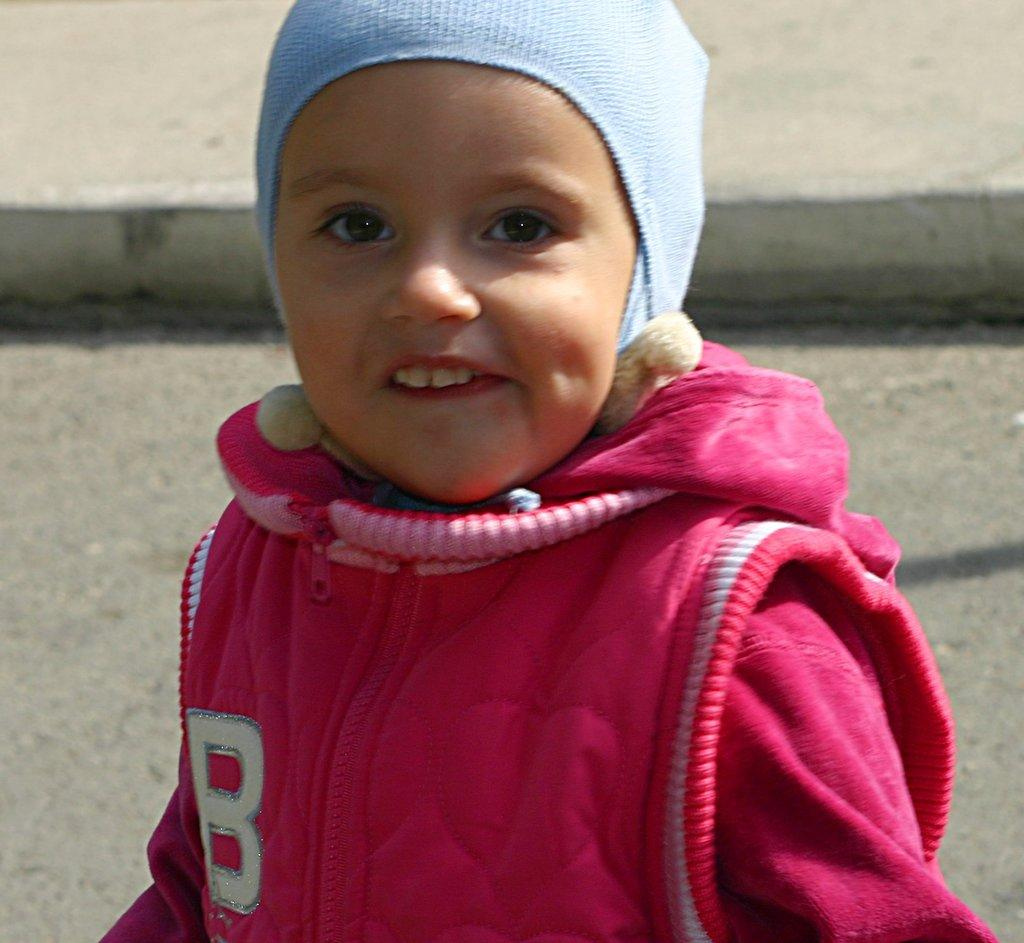What is the main subject of the image? There is a person in the image. Where is the person located in the image? The person is standing on the road. What type of icicle can be seen hanging from the person's veil in the image? There is no icicle or veil present in the image; it features a person standing on the road. 